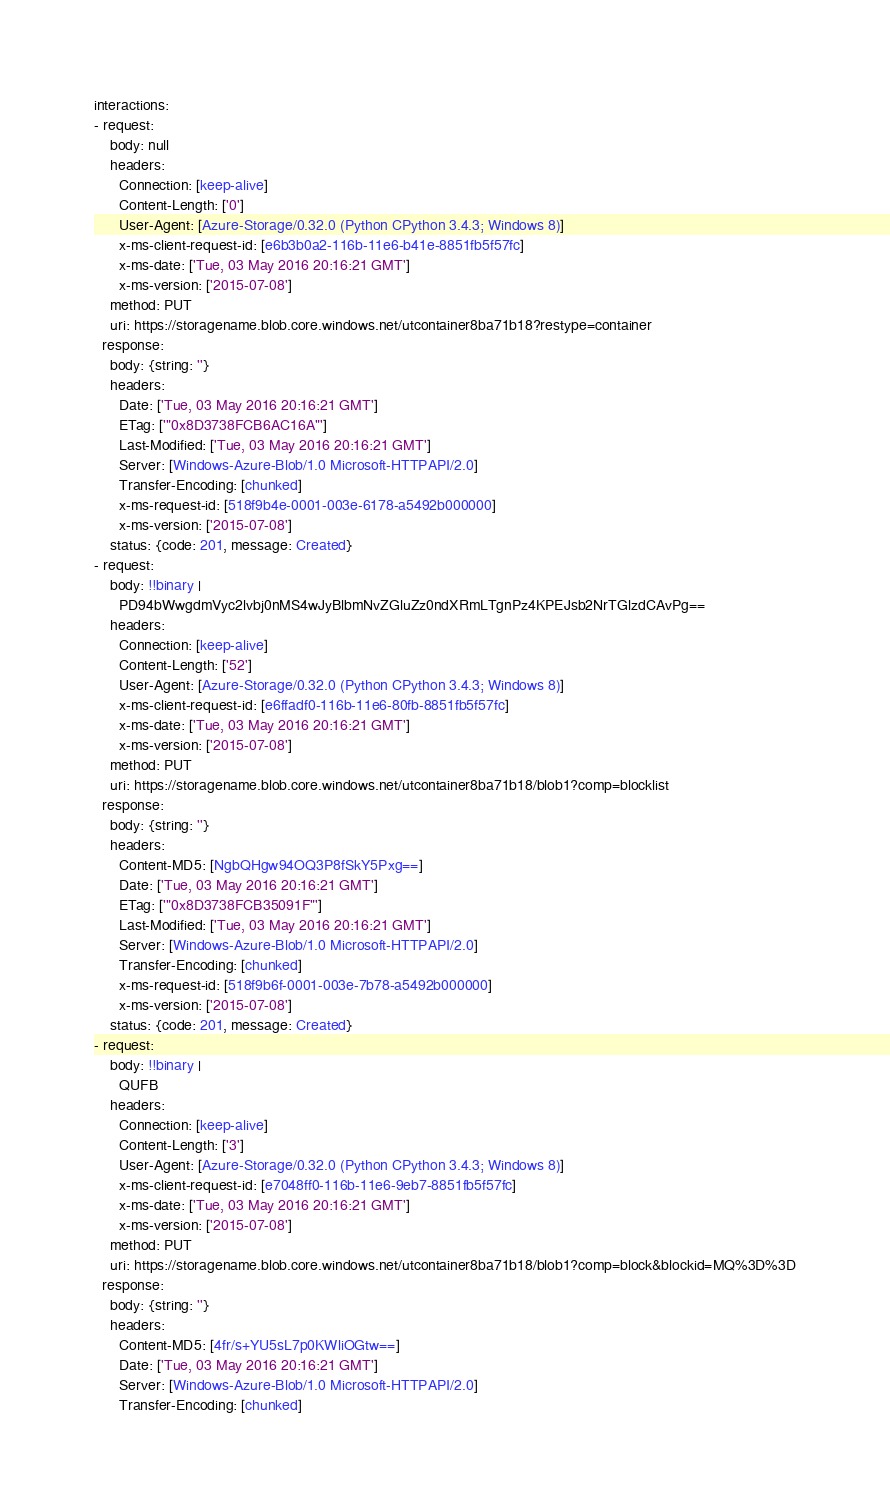<code> <loc_0><loc_0><loc_500><loc_500><_YAML_>interactions:
- request:
    body: null
    headers:
      Connection: [keep-alive]
      Content-Length: ['0']
      User-Agent: [Azure-Storage/0.32.0 (Python CPython 3.4.3; Windows 8)]
      x-ms-client-request-id: [e6b3b0a2-116b-11e6-b41e-8851fb5f57fc]
      x-ms-date: ['Tue, 03 May 2016 20:16:21 GMT']
      x-ms-version: ['2015-07-08']
    method: PUT
    uri: https://storagename.blob.core.windows.net/utcontainer8ba71b18?restype=container
  response:
    body: {string: ''}
    headers:
      Date: ['Tue, 03 May 2016 20:16:21 GMT']
      ETag: ['"0x8D3738FCB6AC16A"']
      Last-Modified: ['Tue, 03 May 2016 20:16:21 GMT']
      Server: [Windows-Azure-Blob/1.0 Microsoft-HTTPAPI/2.0]
      Transfer-Encoding: [chunked]
      x-ms-request-id: [518f9b4e-0001-003e-6178-a5492b000000]
      x-ms-version: ['2015-07-08']
    status: {code: 201, message: Created}
- request:
    body: !!binary |
      PD94bWwgdmVyc2lvbj0nMS4wJyBlbmNvZGluZz0ndXRmLTgnPz4KPEJsb2NrTGlzdCAvPg==
    headers:
      Connection: [keep-alive]
      Content-Length: ['52']
      User-Agent: [Azure-Storage/0.32.0 (Python CPython 3.4.3; Windows 8)]
      x-ms-client-request-id: [e6ffadf0-116b-11e6-80fb-8851fb5f57fc]
      x-ms-date: ['Tue, 03 May 2016 20:16:21 GMT']
      x-ms-version: ['2015-07-08']
    method: PUT
    uri: https://storagename.blob.core.windows.net/utcontainer8ba71b18/blob1?comp=blocklist
  response:
    body: {string: ''}
    headers:
      Content-MD5: [NgbQHgw94OQ3P8fSkY5Pxg==]
      Date: ['Tue, 03 May 2016 20:16:21 GMT']
      ETag: ['"0x8D3738FCB35091F"']
      Last-Modified: ['Tue, 03 May 2016 20:16:21 GMT']
      Server: [Windows-Azure-Blob/1.0 Microsoft-HTTPAPI/2.0]
      Transfer-Encoding: [chunked]
      x-ms-request-id: [518f9b6f-0001-003e-7b78-a5492b000000]
      x-ms-version: ['2015-07-08']
    status: {code: 201, message: Created}
- request:
    body: !!binary |
      QUFB
    headers:
      Connection: [keep-alive]
      Content-Length: ['3']
      User-Agent: [Azure-Storage/0.32.0 (Python CPython 3.4.3; Windows 8)]
      x-ms-client-request-id: [e7048ff0-116b-11e6-9eb7-8851fb5f57fc]
      x-ms-date: ['Tue, 03 May 2016 20:16:21 GMT']
      x-ms-version: ['2015-07-08']
    method: PUT
    uri: https://storagename.blob.core.windows.net/utcontainer8ba71b18/blob1?comp=block&blockid=MQ%3D%3D
  response:
    body: {string: ''}
    headers:
      Content-MD5: [4fr/s+YU5sL7p0KWliOGtw==]
      Date: ['Tue, 03 May 2016 20:16:21 GMT']
      Server: [Windows-Azure-Blob/1.0 Microsoft-HTTPAPI/2.0]
      Transfer-Encoding: [chunked]</code> 